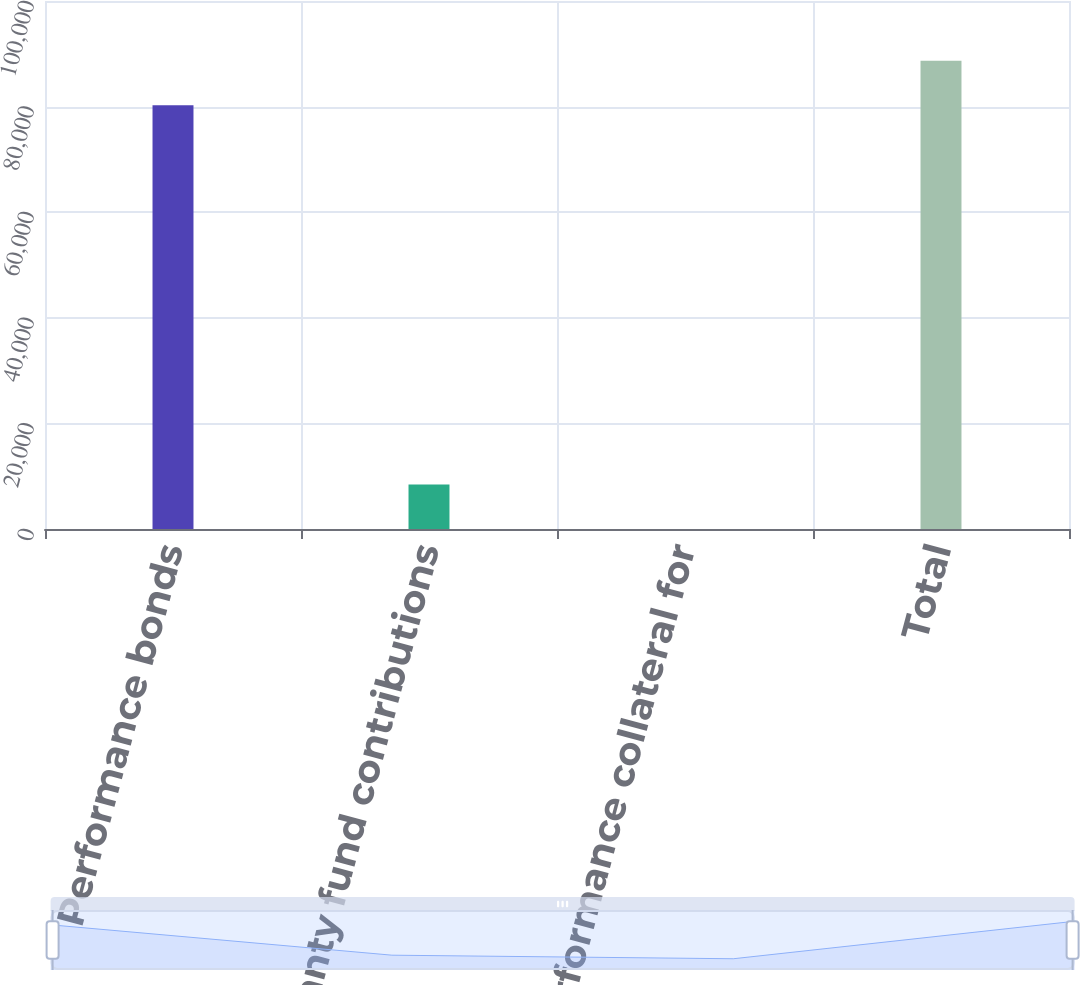Convert chart to OTSL. <chart><loc_0><loc_0><loc_500><loc_500><bar_chart><fcel>Performance bonds<fcel>Guaranty fund contributions<fcel>Performance collateral for<fcel>Total<nl><fcel>80250.7<fcel>8444.34<fcel>12<fcel>88683<nl></chart> 